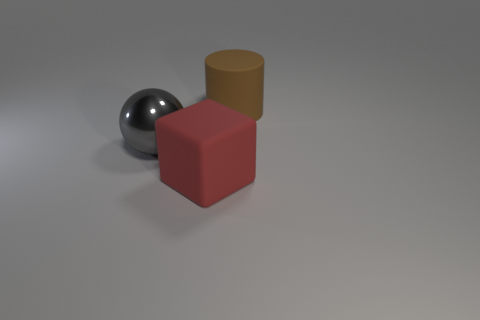Add 3 big shiny objects. How many objects exist? 6 Subtract 0 green cylinders. How many objects are left? 3 Subtract all balls. How many objects are left? 2 Subtract 1 spheres. How many spheres are left? 0 Subtract all brown balls. Subtract all cyan cubes. How many balls are left? 1 Subtract all big cylinders. Subtract all big brown matte cylinders. How many objects are left? 1 Add 2 large brown matte things. How many large brown matte things are left? 3 Add 2 large red matte things. How many large red matte things exist? 3 